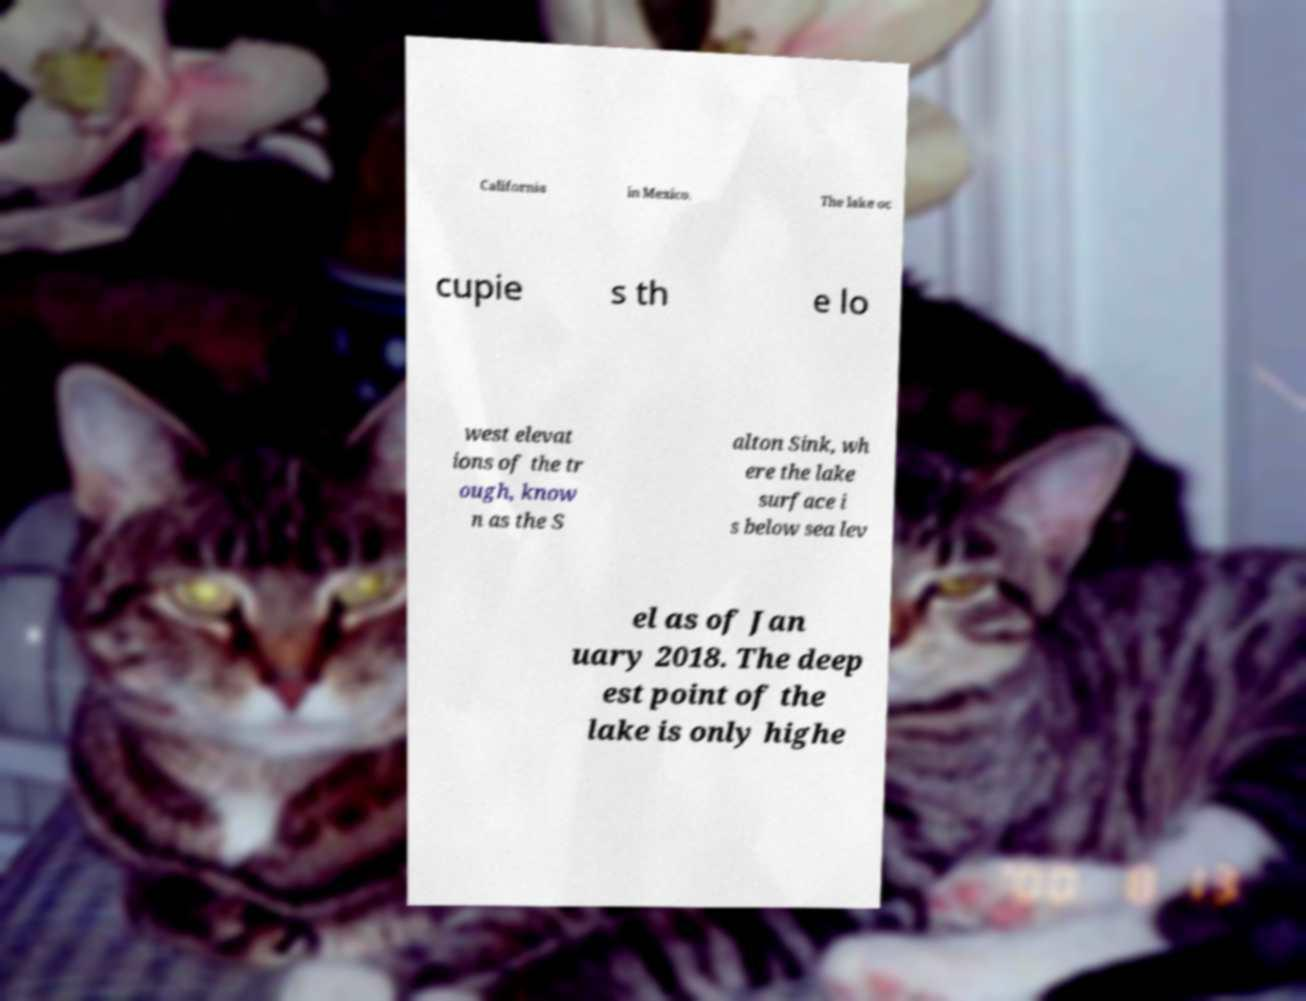I need the written content from this picture converted into text. Can you do that? California in Mexico. The lake oc cupie s th e lo west elevat ions of the tr ough, know n as the S alton Sink, wh ere the lake surface i s below sea lev el as of Jan uary 2018. The deep est point of the lake is only highe 